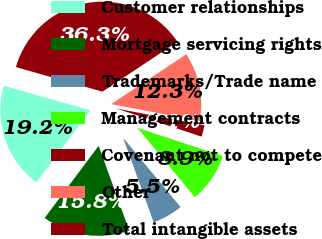Convert chart. <chart><loc_0><loc_0><loc_500><loc_500><pie_chart><fcel>Customer relationships<fcel>Mortgage servicing rights<fcel>Trademarks/Trade name<fcel>Management contracts<fcel>Covenant not to compete<fcel>Other<fcel>Total intangible assets<nl><fcel>19.17%<fcel>15.75%<fcel>5.5%<fcel>8.91%<fcel>2.08%<fcel>12.33%<fcel>36.26%<nl></chart> 